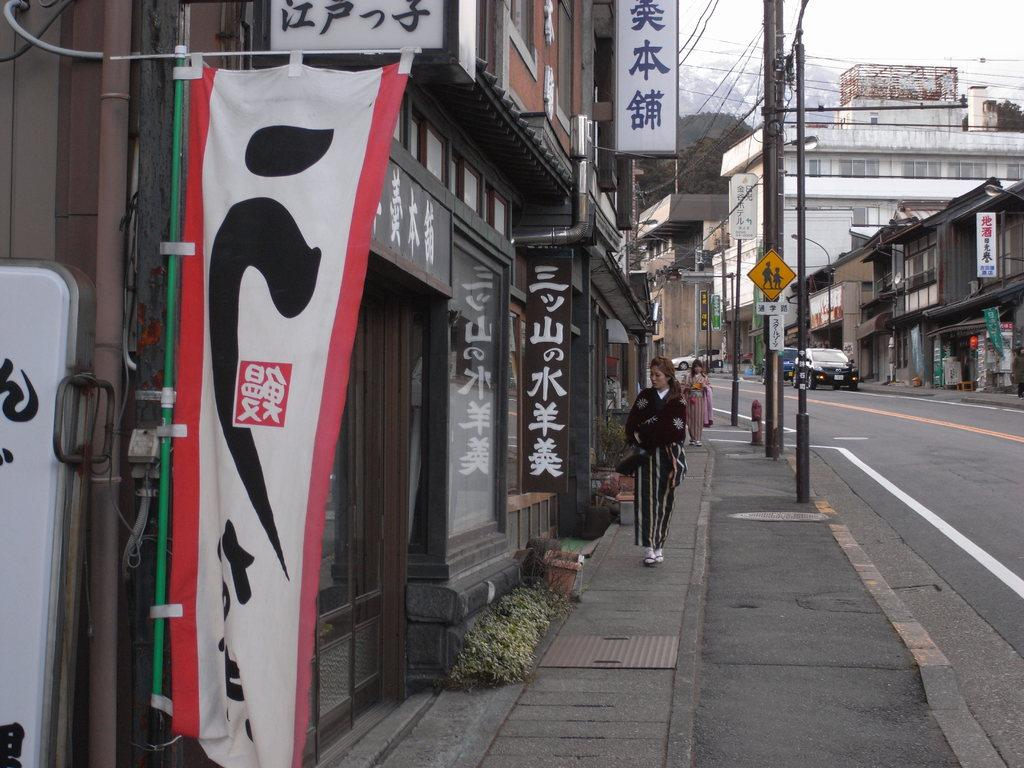What can be seen on the road in the image? There are vehicles on the road in the image. What structures are visible in the image? There are buildings visible in the image. What objects are present in the image that are used for support or attachment? There are poles in the image. What type of information is displayed in the image? There is a signboard in the image. What decorative elements are present in the image? There are banners in the image. What can be seen on the side of the road in the image? There are people walking on a footpath in the image. What type of natural elements are present in the image? Plants are present in the image. Can you tell me how many legs the brain has in the image? There is no brain present in the image, and therefore no legs can be counted. What type of rod is being used by the people walking on the footpath in the image? There is no rod being used by the people walking on the footpath in the image. 